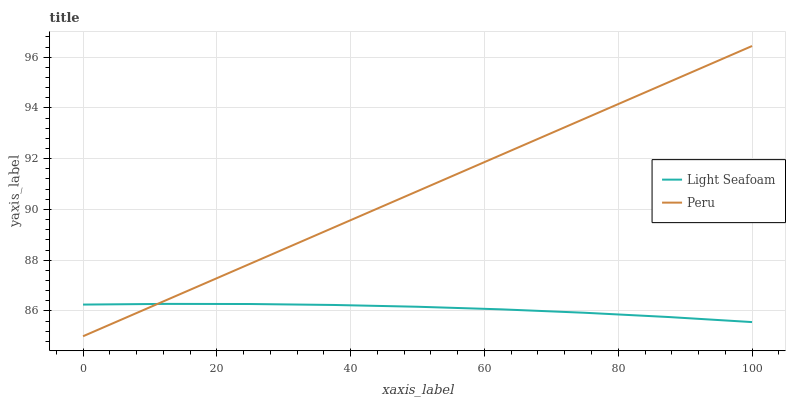Does Light Seafoam have the minimum area under the curve?
Answer yes or no. Yes. Does Peru have the maximum area under the curve?
Answer yes or no. Yes. Does Peru have the minimum area under the curve?
Answer yes or no. No. Is Peru the smoothest?
Answer yes or no. Yes. Is Light Seafoam the roughest?
Answer yes or no. Yes. Is Peru the roughest?
Answer yes or no. No. Does Peru have the lowest value?
Answer yes or no. Yes. Does Peru have the highest value?
Answer yes or no. Yes. Does Peru intersect Light Seafoam?
Answer yes or no. Yes. Is Peru less than Light Seafoam?
Answer yes or no. No. Is Peru greater than Light Seafoam?
Answer yes or no. No. 